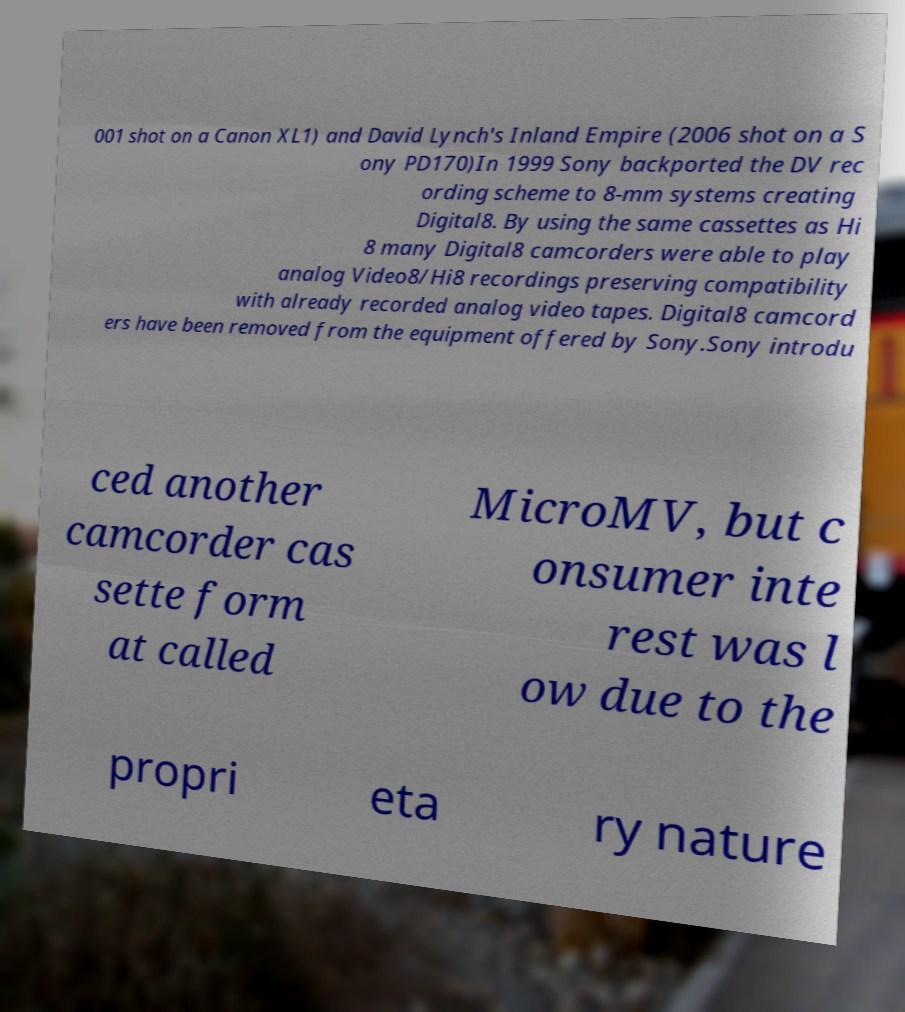Could you extract and type out the text from this image? 001 shot on a Canon XL1) and David Lynch's Inland Empire (2006 shot on a S ony PD170)In 1999 Sony backported the DV rec ording scheme to 8-mm systems creating Digital8. By using the same cassettes as Hi 8 many Digital8 camcorders were able to play analog Video8/Hi8 recordings preserving compatibility with already recorded analog video tapes. Digital8 camcord ers have been removed from the equipment offered by Sony.Sony introdu ced another camcorder cas sette form at called MicroMV, but c onsumer inte rest was l ow due to the propri eta ry nature 